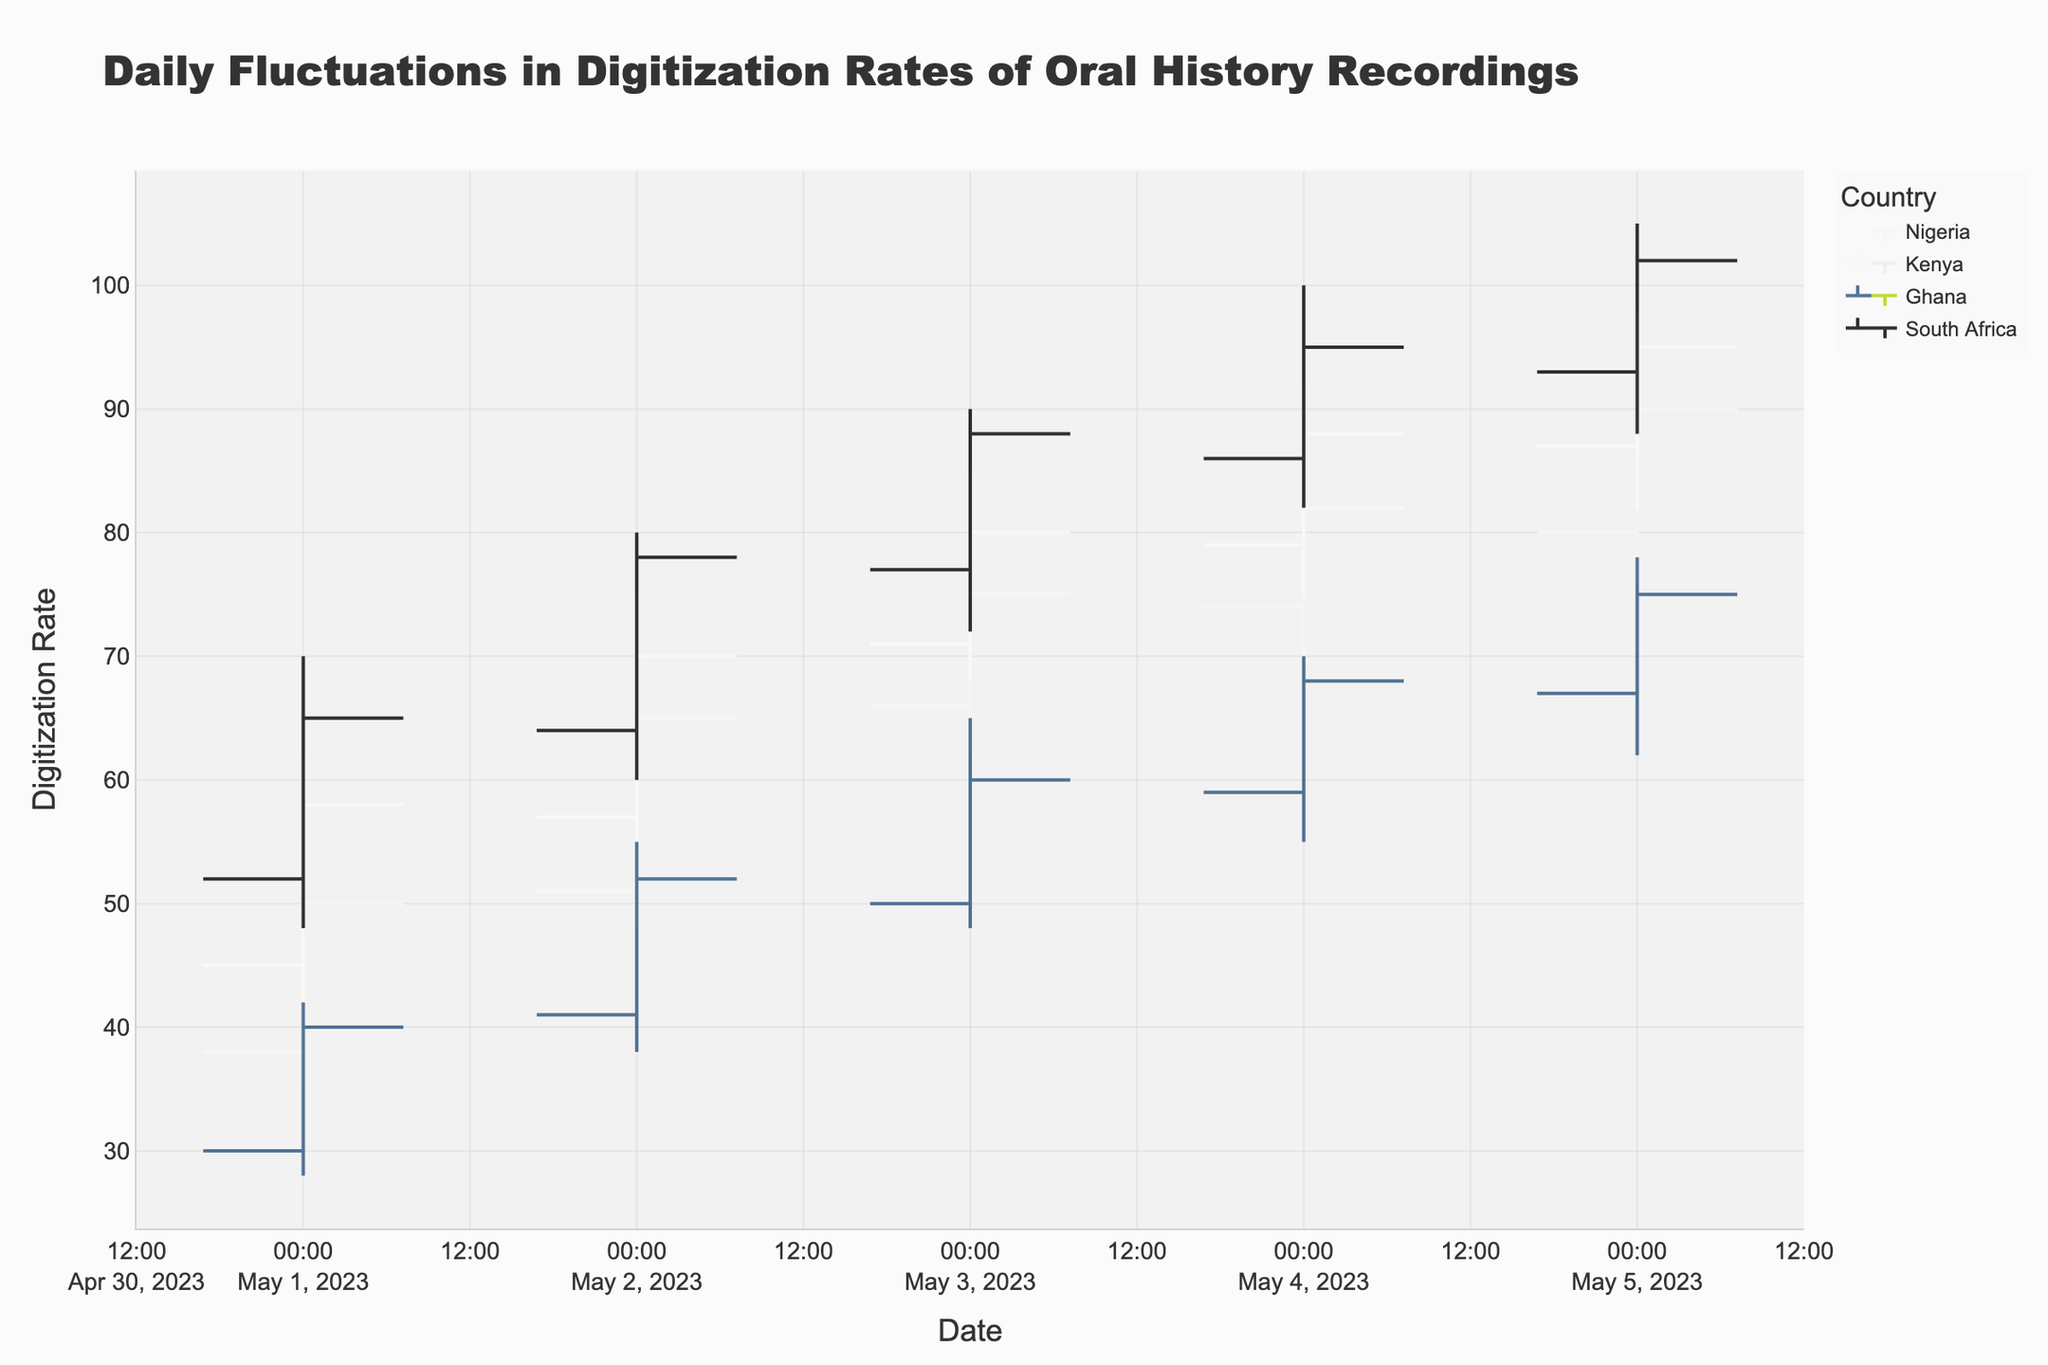what is the title of the figure? The title of the figure is typically displayed at the top of the chart. In this case, it is defined in the code that generates the figure.
Answer: Daily Fluctuations in Digitization Rates of Oral History Recordings How many countries are represented in the figure? The figure displays data for multiple countries, each with distinct traces in the OHLC chart. By examining the legend or the data source, we can identify the number of countries.
Answer: Four Which country had the highest digitization rate on May 1, 2023? By examining the OHLC data points for May 1, the highest digitization rate for each country can be retrieved, and the highest among them is determined. South Africa had the highest rate of 70.
Answer: South Africa What was Kenya's lowest digitization rate on May 3, 2023? By looking at Kenya’s OHLC data on May 3, the 'Low' value indicates the lowest digitization rate.
Answer: 62 Which country had the largest increase in its closing digitization rate from May 1 to May 2? Subtract the closing digitization rate on May 1 from the rate on May 2 for each country. Identify the country with the maximum difference. For Nigeria: 70 - 58 = 12, Kenya: 65 - 50 = 15, Ghana: 52 - 40 = 12, South Africa: 78 - 65 = 13. Kenya has the largest increase of 15.
Answer: Kenya Compare the closing digitization rates of Nigeria and Ghana on May 5, 2023. Which one is higher? By examining the closing digitization rates for Nigeria and Ghana on May 5, we compare them to determine which is higher. Nigeria's closing rate = 95, Ghana's closing rate = 75, therefore, Nigeria's is higher.
Answer: Nigeria Calculate the average closing digitization rate of Ghana from May 1 to May 5, 2023. To find the average, sum up the closing rates for Ghana from May 1 to May 5 and divide by the number of days (5). The closing rates are: 40, 52, 60, 68, 75. Sum = 295, Average = 295 / 5 = 59
Answer: 59 Did South Africa experience an overall increase or decrease in digitization rates from May 1 to May 5? By comparing the closing rates of South Africa on May 1 (65) and May 5 (102), any increase or decrease over this period can be observed. Since 102 > 65, there was an increase.
Answer: Increase On which date did Kenya have the highest digitization rate? Examine the high values for Kenya on all dates and identify the maximum value and its corresponding date. The highest rate for Kenya was 92 on May 5.
Answer: May 5 Explain the pattern of digitization rates in Nigeria between May 1 and May 5. Examine the closing digitization rates of Nigeria over these dates: May 1 (58), May 2 (70), May 3 (80), May 4 (88), May 5 (95). The pattern shows a consistent increase in rates over the period.
Answer: Consistent increase 